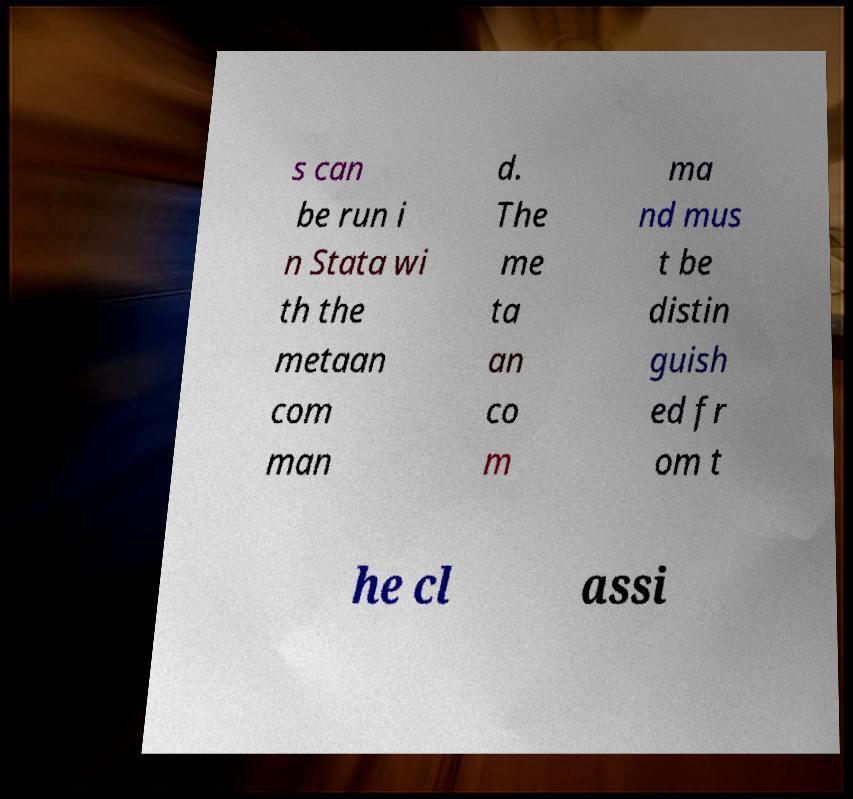Please read and relay the text visible in this image. What does it say? s can be run i n Stata wi th the metaan com man d. The me ta an co m ma nd mus t be distin guish ed fr om t he cl assi 